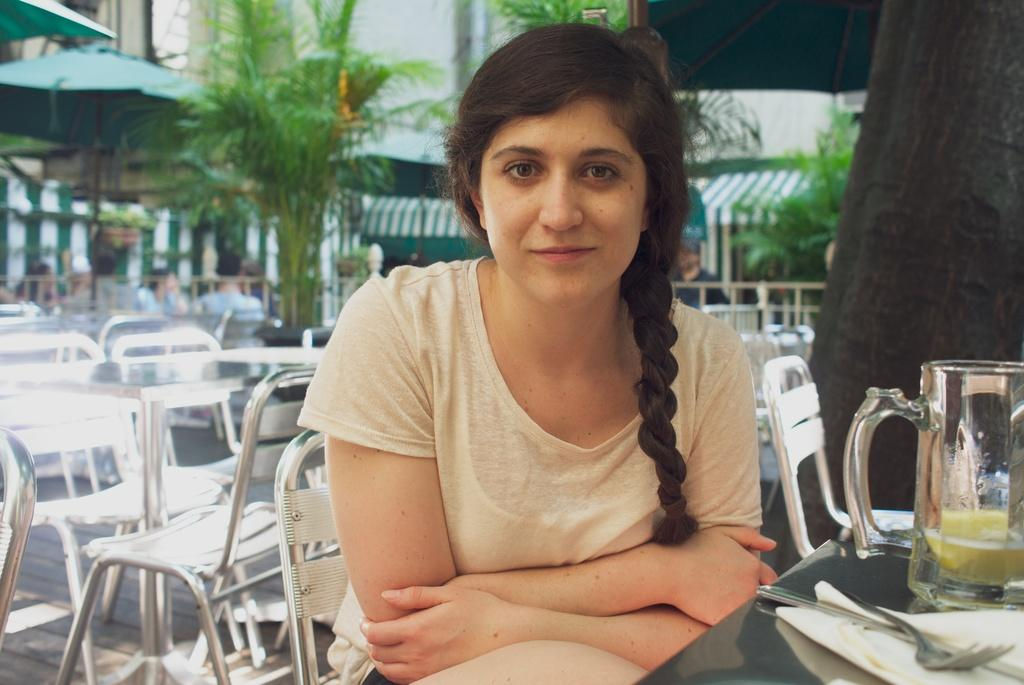What is the woman in the image doing? The woman is sitting in a chair. What is in front of the woman? The woman is in front of a table. What is on the table? The table has glass, a fork, and tissue on it. How many chairs are visible in the image? There are empty chairs in the background. What type of shirt is the woman wearing in the image? The image does not show the woman's shirt, so it cannot be determined from the image. 